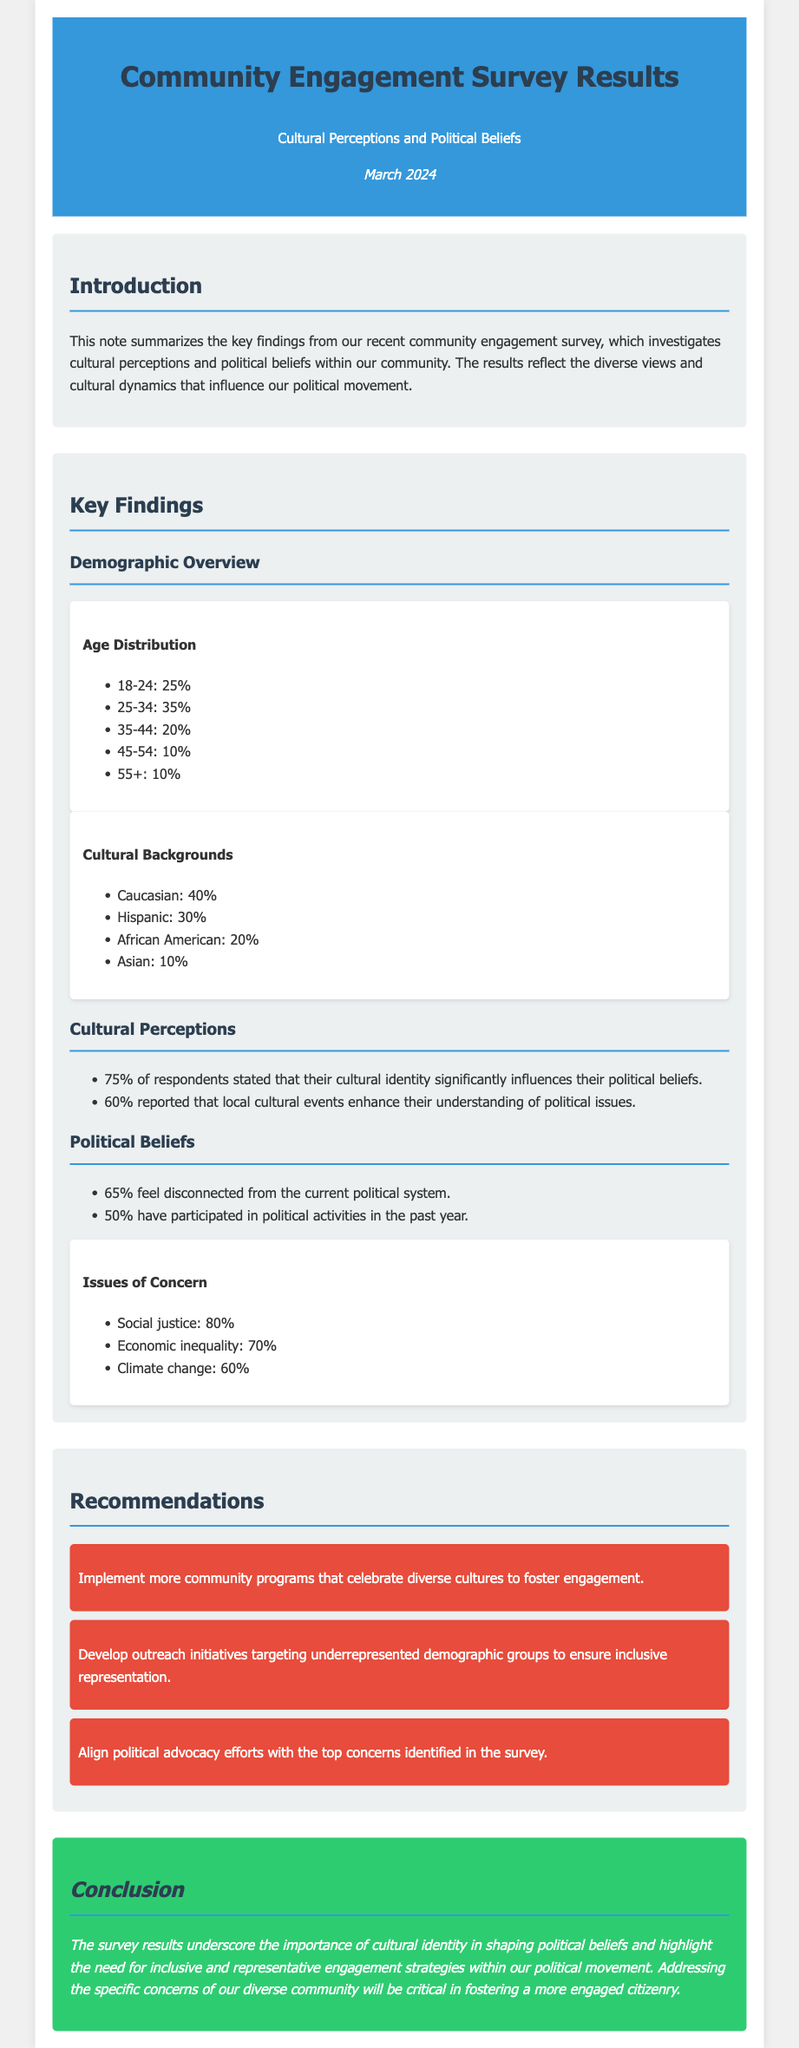what percentage of respondents feel disconnected from the current political system? The document states that 65% of respondents feel disconnected from the current political system.
Answer: 65% what are the top two issues of concern identified in the survey? The document lists social justice and economic inequality as the top two issues of concern, at 80% and 70% respectively.
Answer: Social justice, Economic inequality how many respondents reported that local cultural events enhance their understanding of political issues? The document mentions that 60% of respondents reported this enhancement from local cultural events.
Answer: 60% what is the age group representing the largest segment of respondents? The age group with the largest percentage is 25-34, which accounts for 35% of the respondents.
Answer: 25-34 what recommendation emphasizes celebrating diverse cultures? One of the recommendations specifies implementing more community programs that celebrate diverse cultures.
Answer: Implement more community programs how many respondents participated in political activities in the past year? The document states that 50% of respondents have participated in political activities in the past year.
Answer: 50% what cultural background represents the smallest percentage of respondents? The document indicates that the Asian cultural background represents the smallest percentage at 10%.
Answer: Asian which demographic group is recommended for outreach initiatives? The document suggests targeting underrepresented demographic groups for outreach initiatives.
Answer: Underrepresented demographic groups 